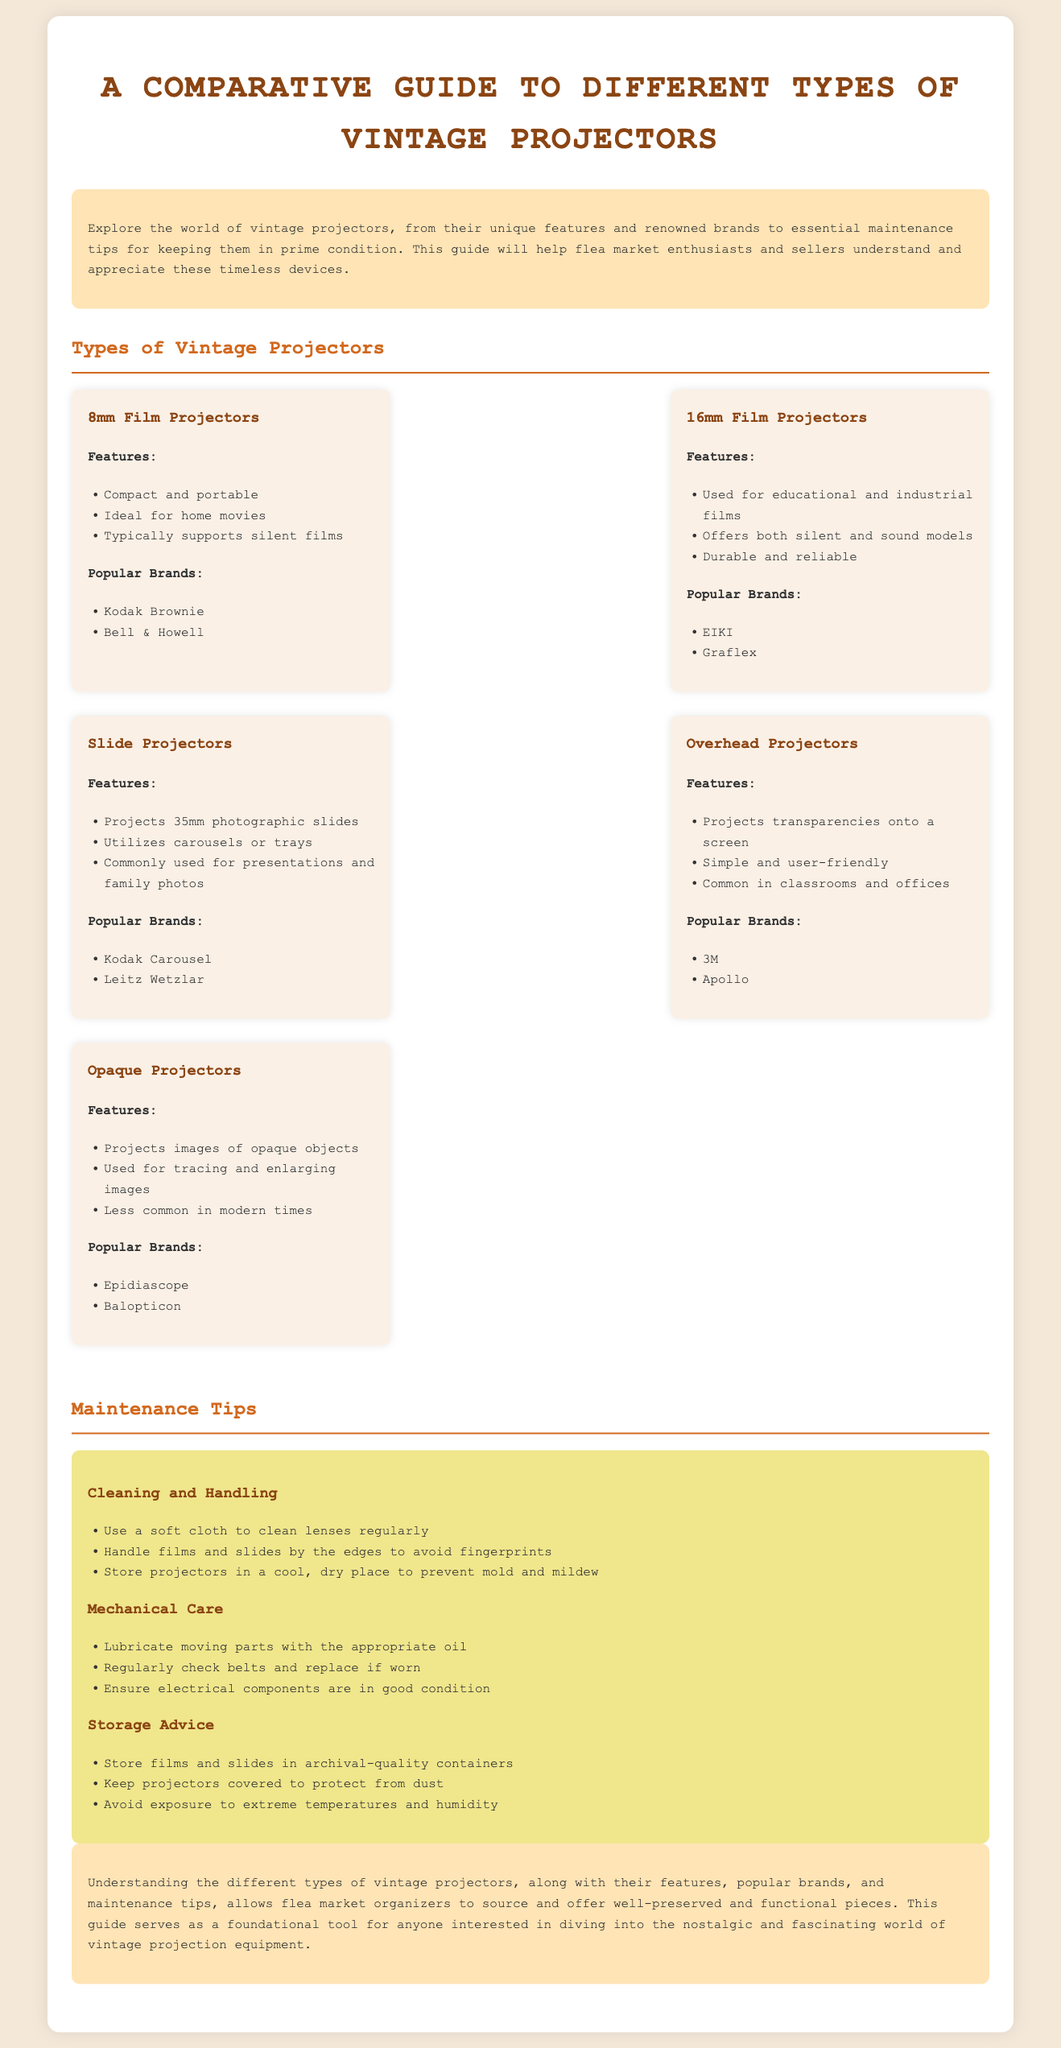what are the features of 16mm Film Projectors? The features listed include educational and industrial use, offers both silent and sound models, and durable and reliable.
Answer: used for educational and industrial films which brand is a popular choice for Slide Projectors? The document states that Kodak Carousel is a popular brand for Slide Projectors.
Answer: Kodak Carousel how many types of vintage projectors are listed in the document? The document presents five types of vintage projectors.
Answer: five what is recommended for cleaning lenses? The maintenance section advises using a soft cloth to clean lenses regularly.
Answer: soft cloth which projector type is ideal for home movies? The document states that 8mm Film Projectors are ideal for home movies.
Answer: 8mm Film Projectors what type of projectors utilizes carousels or trays? Slide Projectors utilize carousels or trays according to the document.
Answer: Slide Projectors what should be done with moving parts of projectors? The document recommends lubricating moving parts with the appropriate oil.
Answer: lubricate which vintage projector brand is less common in modern times? The document mentions Opaque Projectors are less common in modern times.
Answer: Opaque Projectors 